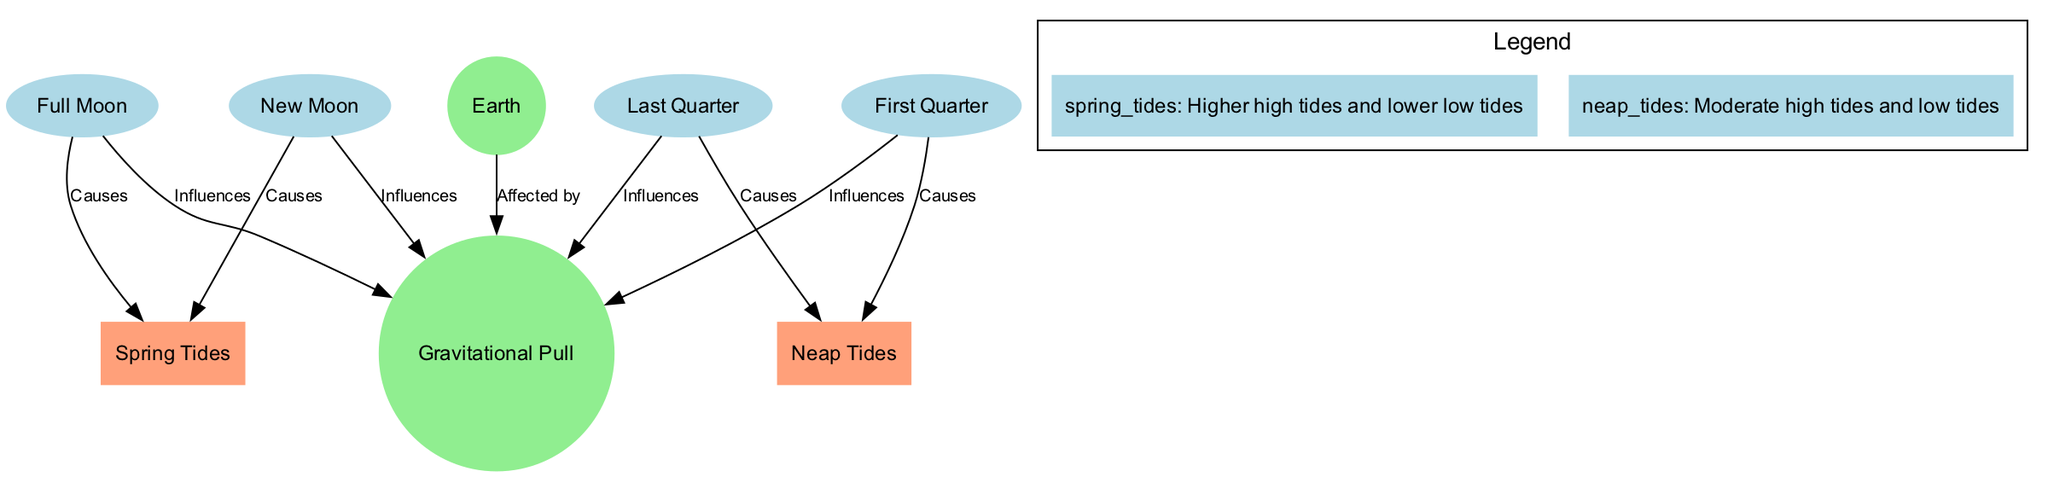What causes spring tides? According to the diagram, spring tides are caused by both the new moon and the full moon, as indicated by the edges leading from these nodes to the spring tides node labeled "Causes."
Answer: New Moon, Full Moon How many phases of the moon are represented in the diagram? The diagram includes four phases of the moon: new moon, first quarter, full moon, and last quarter. Counting these nodes gives us a total of four.
Answer: 4 What type of tides do first quarter and last quarter moons cause? Both the first quarter and last quarter phases of the moon lead to neap tides as shown by the edges labeled "Causes" pointing to the neap tides node.
Answer: Neap Tides Which node represents the gravitational pull? The node labeled "Gravitational Pull" directly appears in the diagram as gravity, and the edges indicate its relationship with other nodes.
Answer: Gravity What effect does the new moon have on gravity? The diagram shows that the new moon influences gravity, as indicated by the edge leading from the new moon node to the gravity node labeled "Influences."
Answer: Influences Which tides are associated with higher high tides? The diagram explicitly states that spring tides are associated with higher high tides, as mentioned in the legend section.
Answer: Spring Tides Which phase of the moon is linked to neap tides? The first quarter phase is linked to neap tides, as shown in the diagram where there is an edge labeled "Causes" connecting the first quarter to neap tides.
Answer: First Quarter What relationship does the Earth have with gravity? The diagram has an edge from the Earth node to the gravity node labeled "Affected by," indicating that Earth is affected by gravity.
Answer: Affected by What are the characteristics of neap tides? In the legend, neap tides are described as having moderate high tides and low tides, summarizing their characteristics directly from the diagram.
Answer: Moderate high tides and low tides 